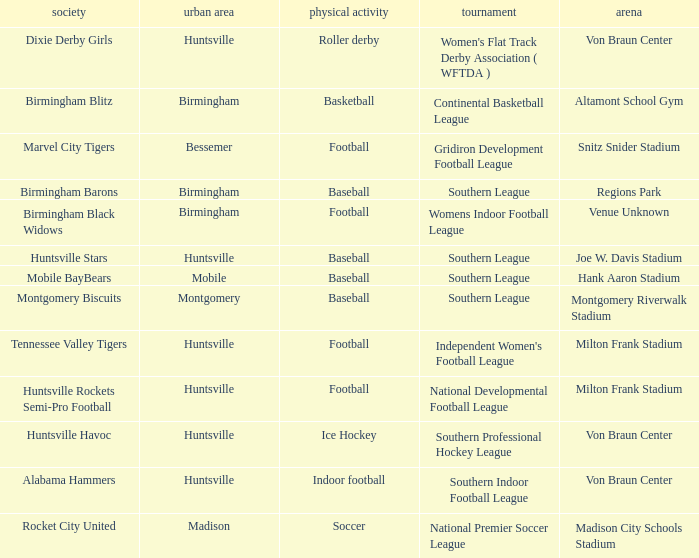Which sport had the club of the Montgomery Biscuits? Baseball. Could you help me parse every detail presented in this table? {'header': ['society', 'urban area', 'physical activity', 'tournament', 'arena'], 'rows': [['Dixie Derby Girls', 'Huntsville', 'Roller derby', "Women's Flat Track Derby Association ( WFTDA )", 'Von Braun Center'], ['Birmingham Blitz', 'Birmingham', 'Basketball', 'Continental Basketball League', 'Altamont School Gym'], ['Marvel City Tigers', 'Bessemer', 'Football', 'Gridiron Development Football League', 'Snitz Snider Stadium'], ['Birmingham Barons', 'Birmingham', 'Baseball', 'Southern League', 'Regions Park'], ['Birmingham Black Widows', 'Birmingham', 'Football', 'Womens Indoor Football League', 'Venue Unknown'], ['Huntsville Stars', 'Huntsville', 'Baseball', 'Southern League', 'Joe W. Davis Stadium'], ['Mobile BayBears', 'Mobile', 'Baseball', 'Southern League', 'Hank Aaron Stadium'], ['Montgomery Biscuits', 'Montgomery', 'Baseball', 'Southern League', 'Montgomery Riverwalk Stadium'], ['Tennessee Valley Tigers', 'Huntsville', 'Football', "Independent Women's Football League", 'Milton Frank Stadium'], ['Huntsville Rockets Semi-Pro Football', 'Huntsville', 'Football', 'National Developmental Football League', 'Milton Frank Stadium'], ['Huntsville Havoc', 'Huntsville', 'Ice Hockey', 'Southern Professional Hockey League', 'Von Braun Center'], ['Alabama Hammers', 'Huntsville', 'Indoor football', 'Southern Indoor Football League', 'Von Braun Center'], ['Rocket City United', 'Madison', 'Soccer', 'National Premier Soccer League', 'Madison City Schools Stadium']]} 